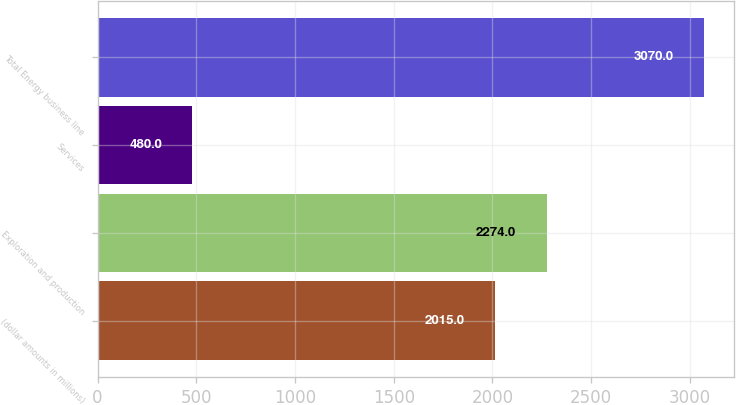<chart> <loc_0><loc_0><loc_500><loc_500><bar_chart><fcel>(dollar amounts in millions)<fcel>Exploration and production<fcel>Services<fcel>Total Energy business line<nl><fcel>2015<fcel>2274<fcel>480<fcel>3070<nl></chart> 